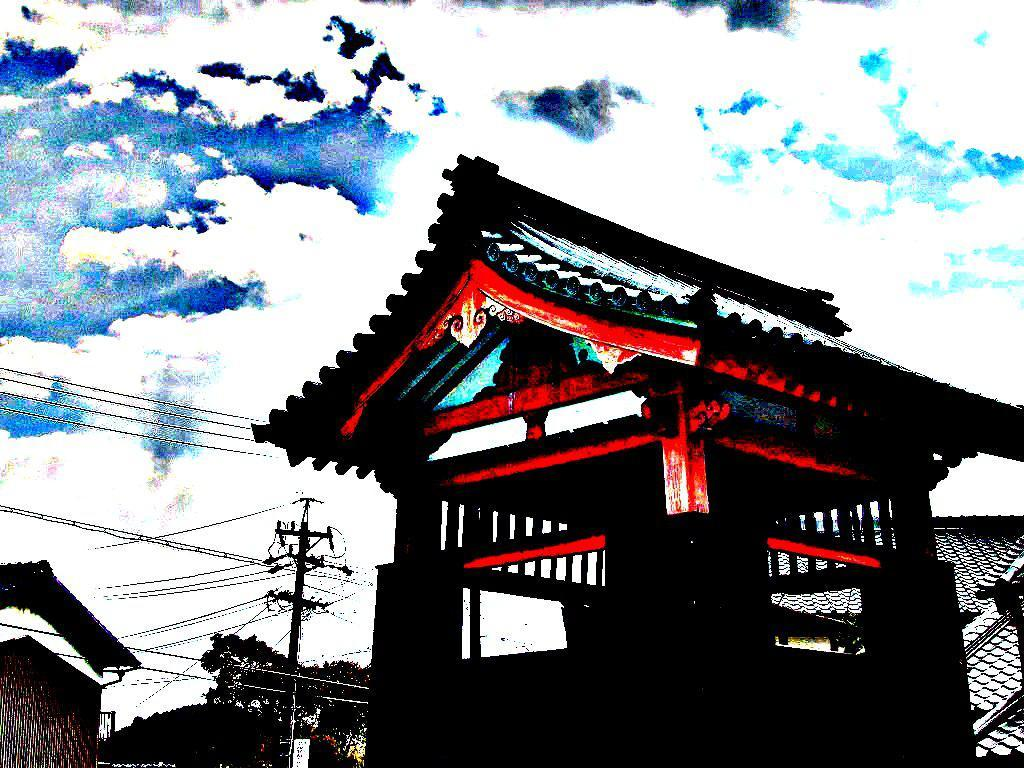What can be said about the nature of the image? The image is edited. What type of structures can be seen in the image? There are buildings in the image. What type of vegetation is present in the image? There are trees in the image. What type of infrastructure is present in the image? There is an electric pole and current wires in the image. What is visible in the background of the image? The sky is visible in the background of the image. How many clocks are hanging on the trees in the image? There are no clocks hanging on the trees in the image. What type of sport is being played in the image? There is no sport being played in the image. 